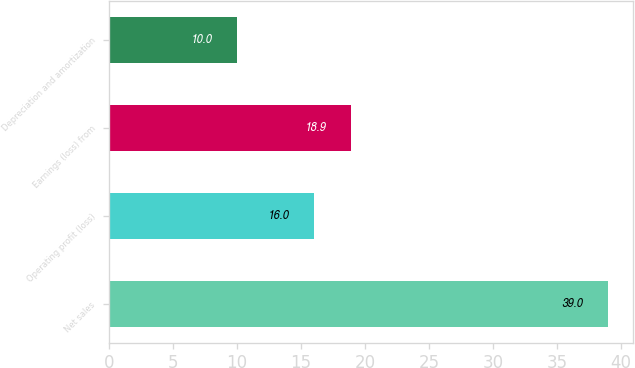<chart> <loc_0><loc_0><loc_500><loc_500><bar_chart><fcel>Net sales<fcel>Operating profit (loss)<fcel>Earnings (loss) from<fcel>Depreciation and amortization<nl><fcel>39<fcel>16<fcel>18.9<fcel>10<nl></chart> 